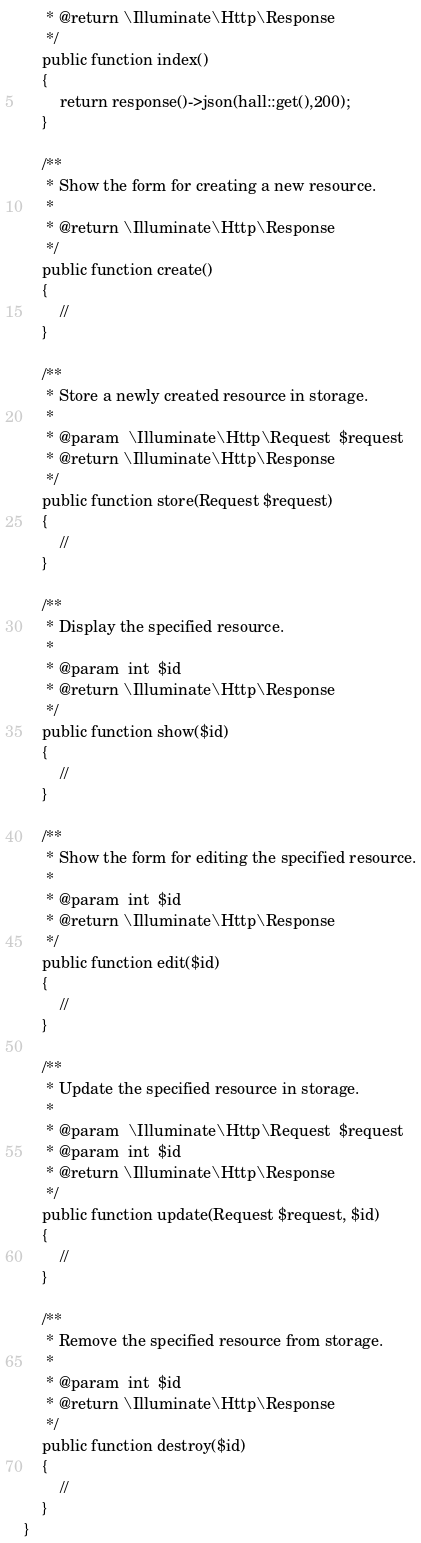Convert code to text. <code><loc_0><loc_0><loc_500><loc_500><_PHP_>     * @return \Illuminate\Http\Response
     */
    public function index()
    {
        return response()->json(hall::get(),200);
    }

    /**
     * Show the form for creating a new resource.
     *
     * @return \Illuminate\Http\Response
     */
    public function create()
    {
        //
    }

    /**
     * Store a newly created resource in storage.
     *
     * @param  \Illuminate\Http\Request  $request
     * @return \Illuminate\Http\Response
     */
    public function store(Request $request)
    {
        //
    }

    /**
     * Display the specified resource.
     *
     * @param  int  $id
     * @return \Illuminate\Http\Response
     */
    public function show($id)
    {
        //
    }

    /**
     * Show the form for editing the specified resource.
     *
     * @param  int  $id
     * @return \Illuminate\Http\Response
     */
    public function edit($id)
    {
        //
    }

    /**
     * Update the specified resource in storage.
     *
     * @param  \Illuminate\Http\Request  $request
     * @param  int  $id
     * @return \Illuminate\Http\Response
     */
    public function update(Request $request, $id)
    {
        //
    }

    /**
     * Remove the specified resource from storage.
     *
     * @param  int  $id
     * @return \Illuminate\Http\Response
     */
    public function destroy($id)
    {
        //
    }
}
</code> 